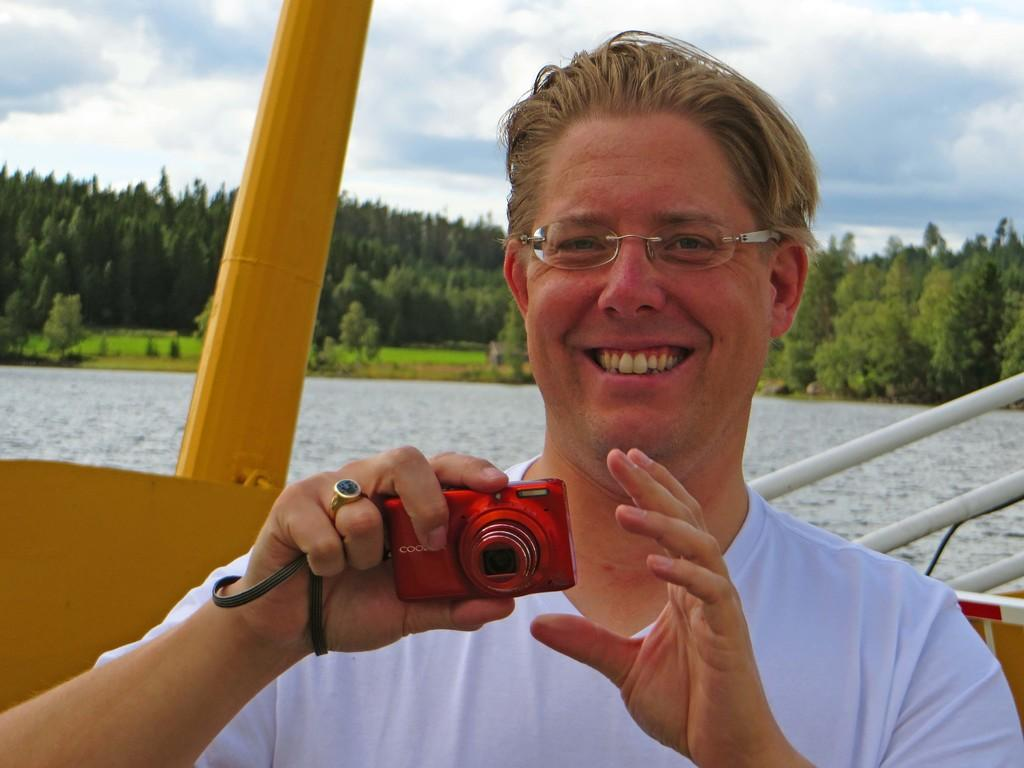Who or what is the main subject in the image? There is a person in the image. What is the person holding in the image? The person is holding a red color camera. What can be seen in the background of the image? There is water and trees visible in the background of the image. What type of rake is the person using to take a picture in the image? There is no rake present in the image; the person is holding a red color camera. Who is the manager of the person taking the picture in the image? There is no information about a manager in the image; it only shows a person holding a camera. 